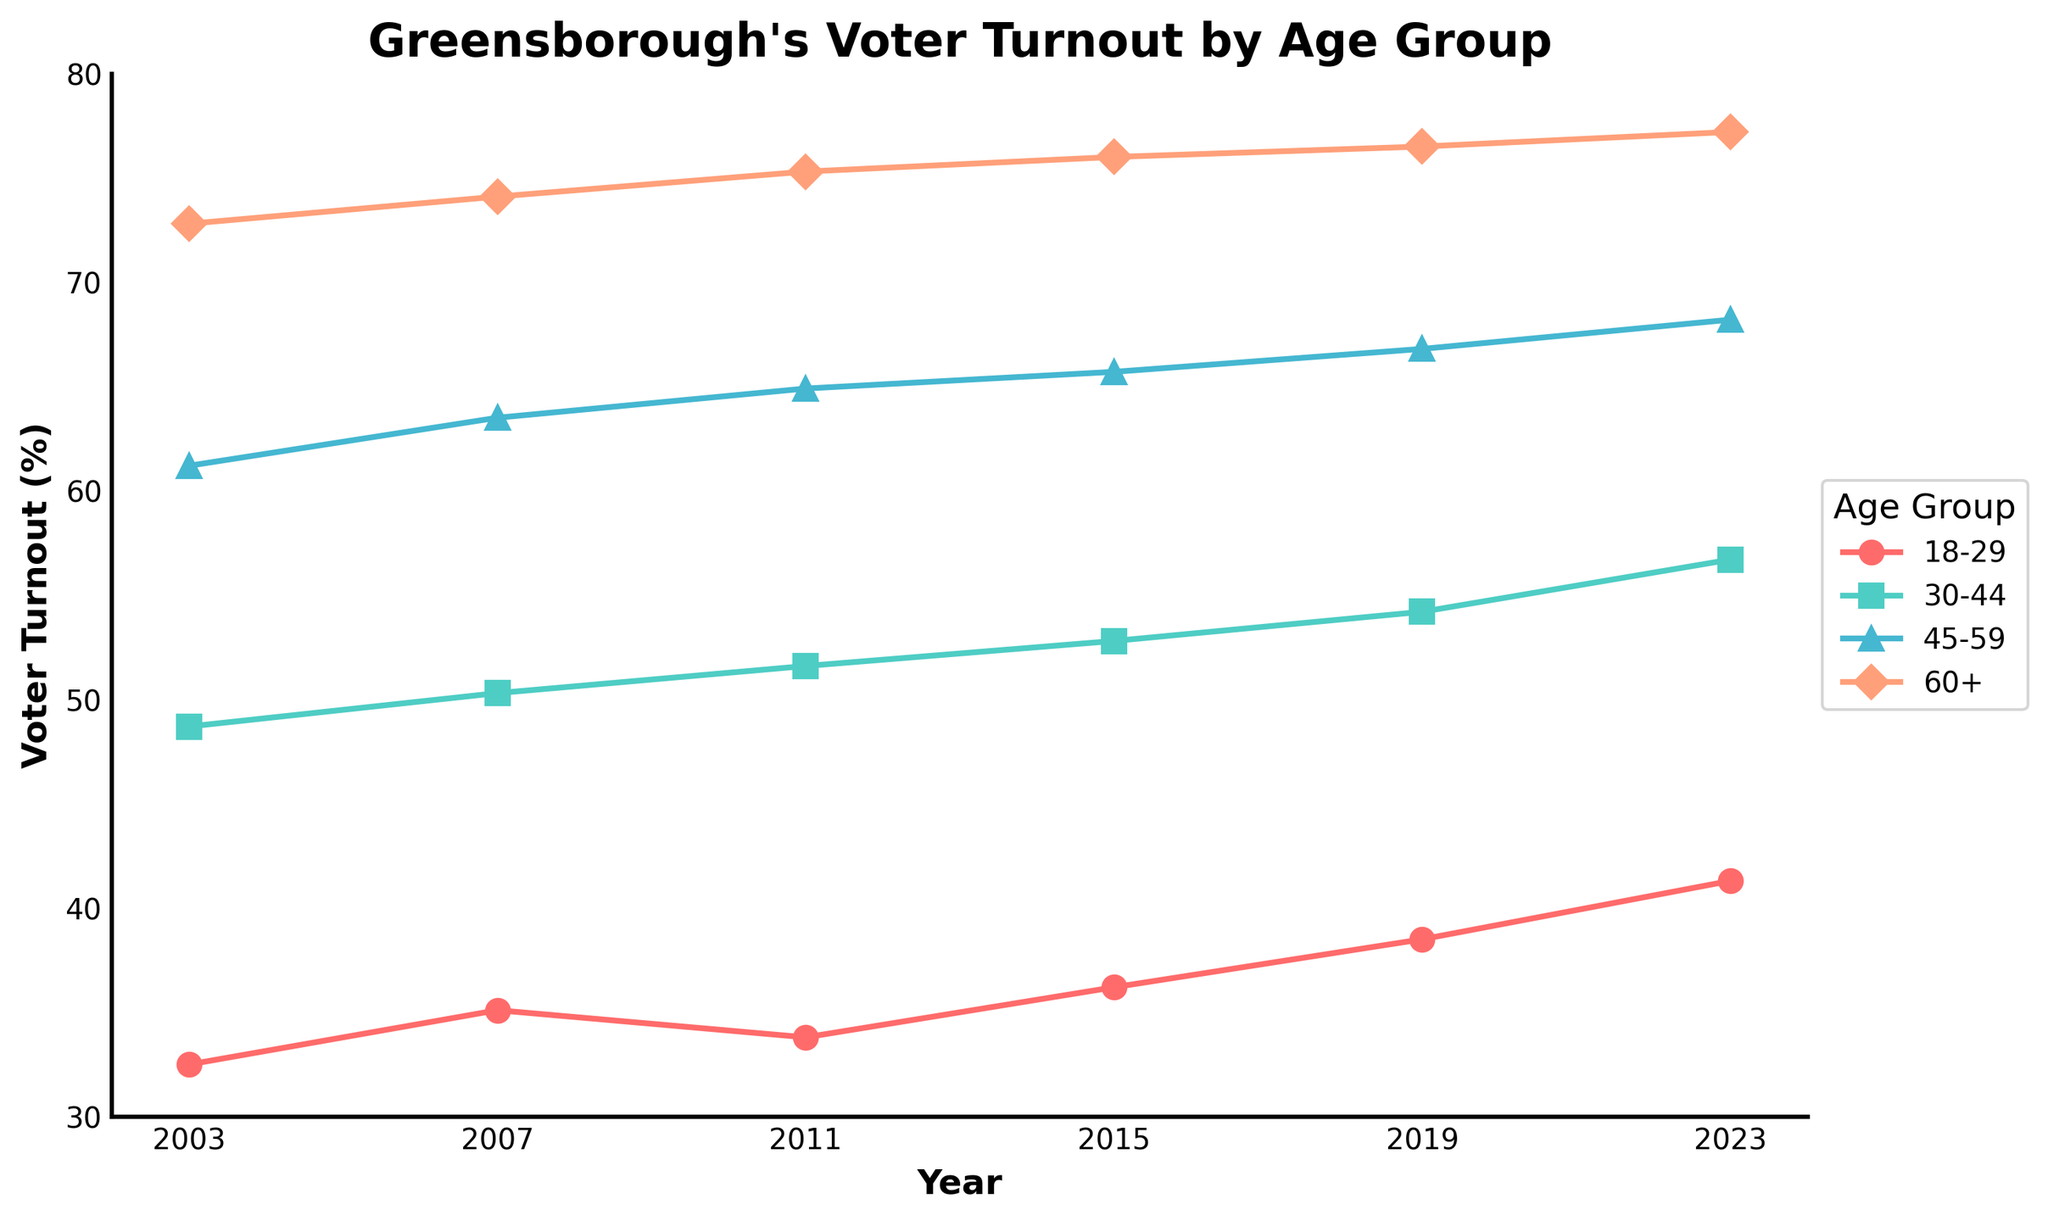what is the highest voter turnout rate among all age groups in 2023? To find the highest voter turnout rate among all age groups in 2023, look at the data points for each age group in that year. The 60+ age group has the highest rate of 77.2%.
Answer: 77.2% What is the percentage increase in voter turnout for the 18-29 age group from 2003 to 2023? Subtract the 2003 voter turnout rate (32.5%) for the 18-29 age group from the 2023 voter turnout rate (41.3%), then divide by the 2003 rate and multiply by 100 to find the percentage increase. This yields ((41.3 - 32.5) / 32.5) * 100 = 27.08%.
Answer: 27.08% Which age group had the smallest increase in voter turnout between 2003 and 2023? Subtract the 2003 voter turnout rates from the 2023 rates for each age group to determine the increase: 18-29 (8.8%), 30-44 (8.0%), 45-59 (7.0%), 60+ (4.4%). The 60+ age group had the smallest increase with 4.4%.
Answer: 60+ In which year between 2003 and 2023 did the voter turnout for the 30-44 age group first surpass 50%? Check the voter turnout rates for the 30-44 age group year by year to see when it first exceeds 50%. The rate first surpasses 50% in 2007, when it was 50.3%.
Answer: 2007 How much greater was the voter turnout rate for the 60+ age group compared to the 18-29 age group in 2011? Subtract the 2011 voter turnout rate for the 18-29 age group (33.8%) from the 60+ age group (75.3%) to find the difference, which is 75.3% - 33.8% = 41.5%.
Answer: 41.5% Which age group had the steadiest increase in voter turnout from 2003 to 2023? Calculate the increases for each age group: 18-29 (8.8%), 30-44 (8.0%), 45-59 (7.0%), 60+ (4.4%). The steadiest increase (smallest fluctuations) appears in the 60+ age group with a consistent growth pattern.
Answer: 60+ How many age groups had a voter turnout rate above 60% every year from 2011 onwards? For each year from 2011 onwards, count the age groups with a voter turnout rate above 60%. The 45-59 and 60+ age groups meet this criterion every year.
Answer: 2 What is the average voter turnout rate for the 45-59 age group across all the years given? Add up the voter turnout rates for the 45-59 age group (61.2%, 63.5%, 64.9%, 65.7%, 66.8%, 68.2%) and divide by the number of years (6). The average is (61.2 + 63.5 + 64.9 + 65.7 + 66.8 + 68.2) / 6 = 65.05%.
Answer: 65.05% 